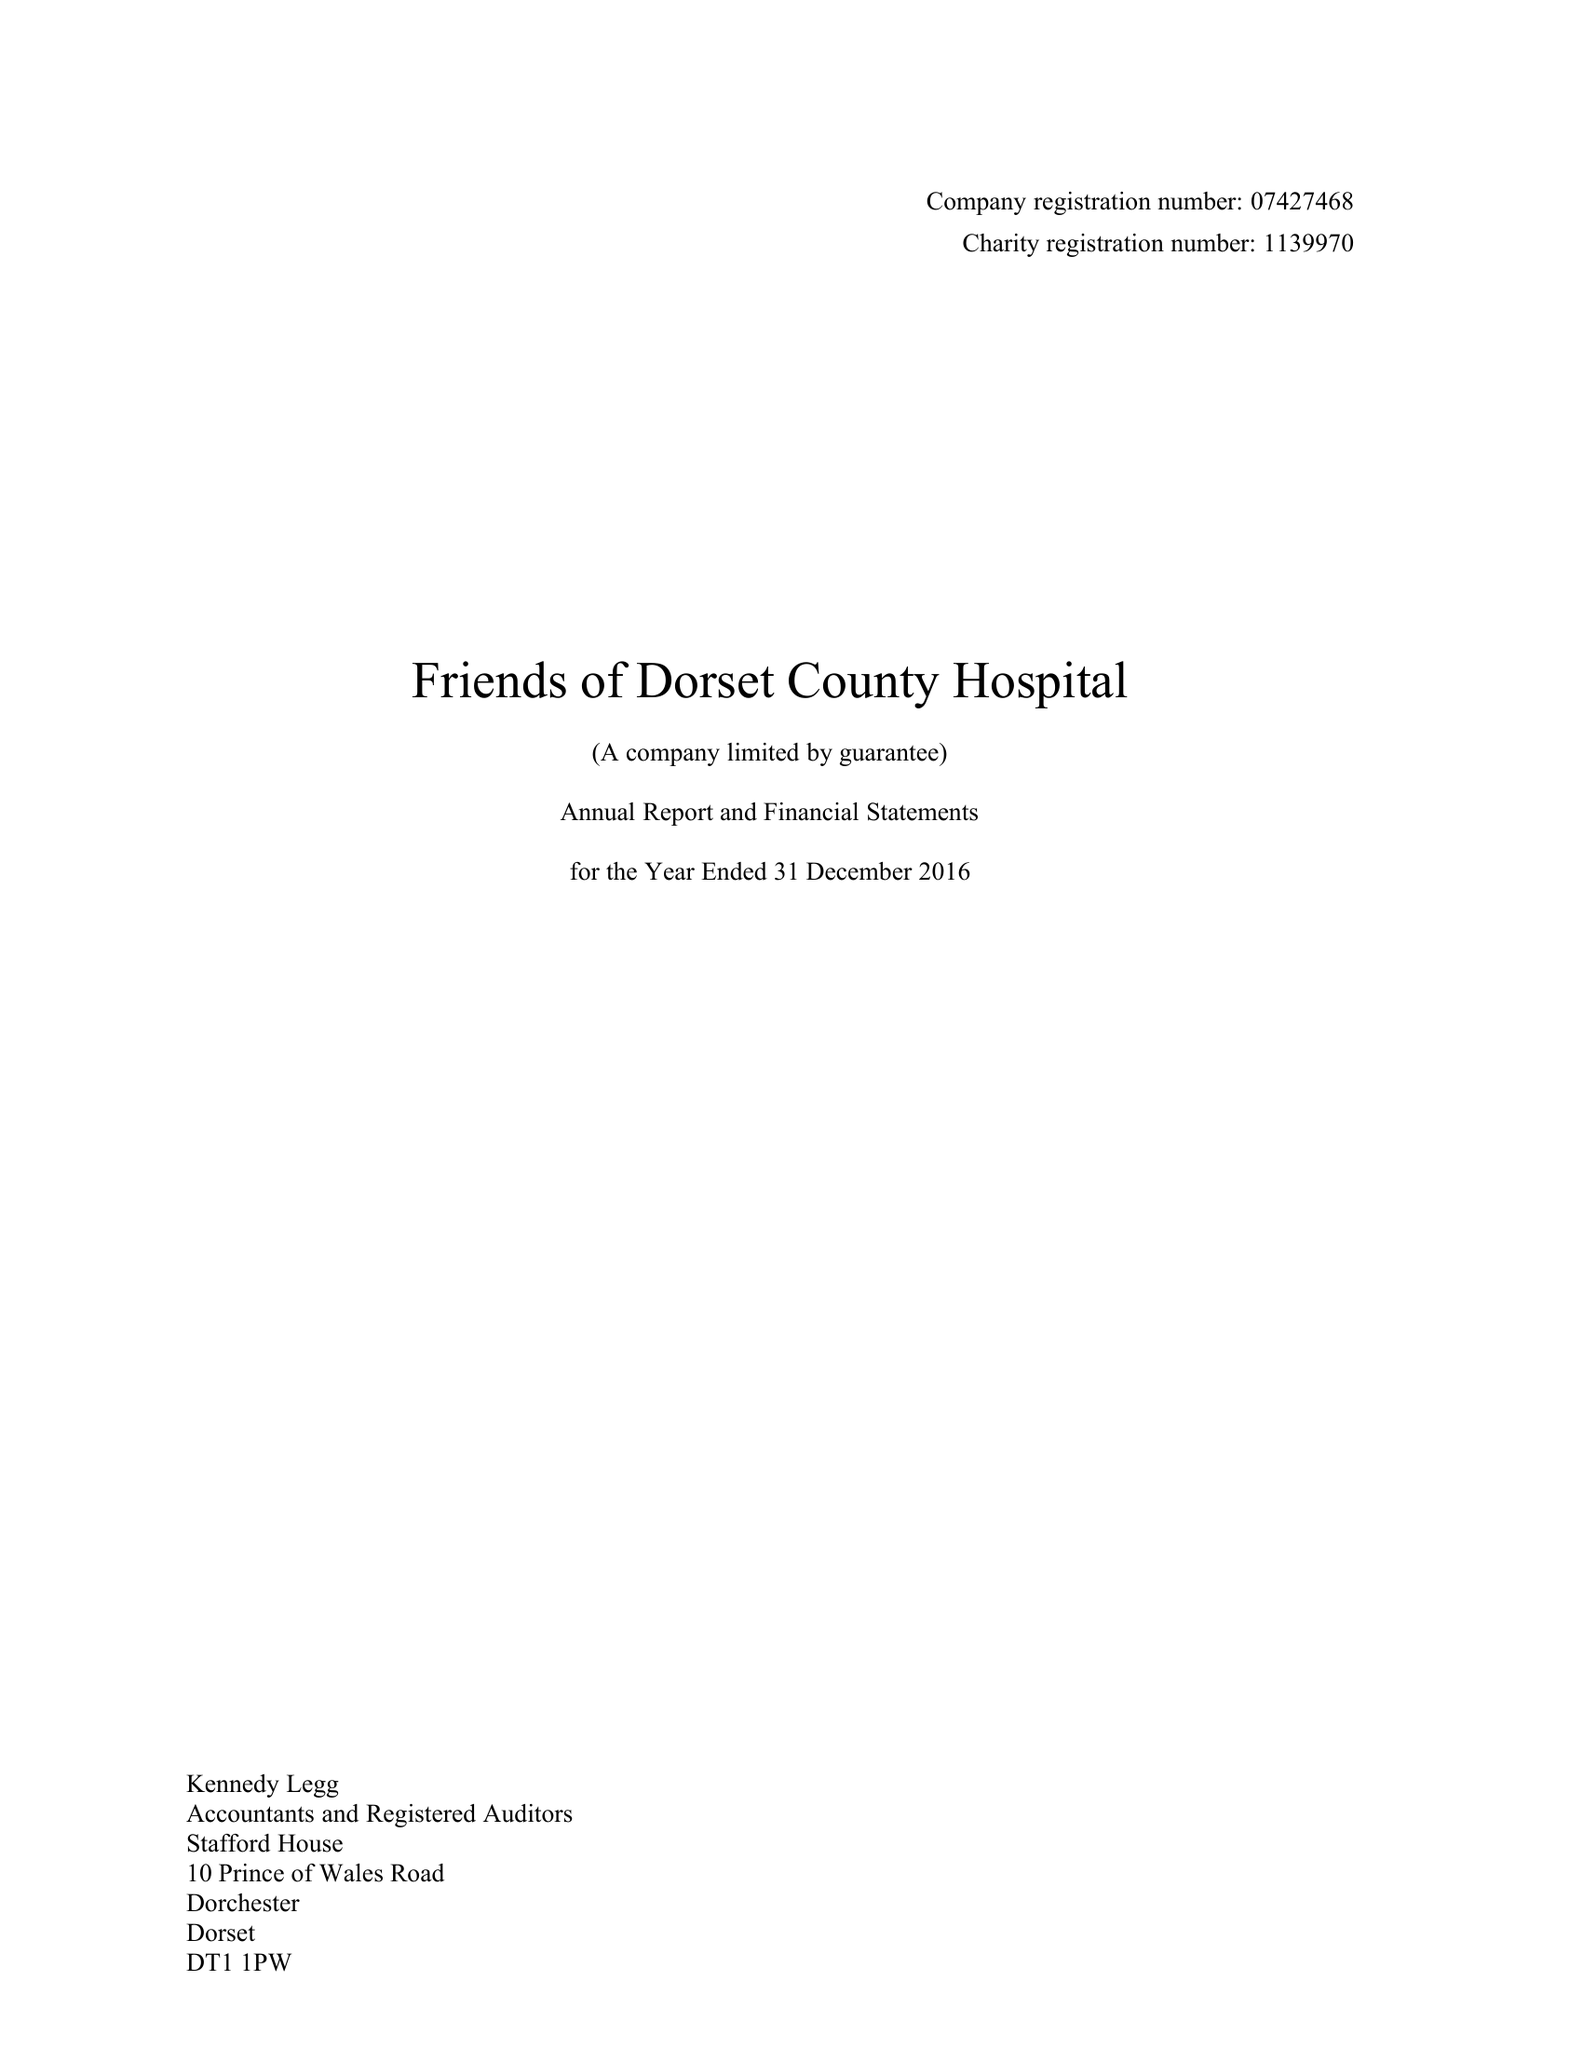What is the value for the charity_name?
Answer the question using a single word or phrase. Friends Of Dorset County Hospital 